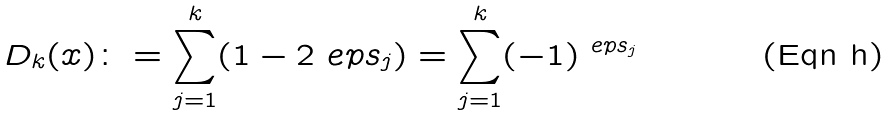<formula> <loc_0><loc_0><loc_500><loc_500>D _ { k } ( x ) \colon = \sum _ { j = 1 } ^ { k } ( 1 - 2 \ e p s _ { j } ) = \sum _ { j = 1 } ^ { k } ( - 1 ) ^ { \ e p s _ { j } }</formula> 